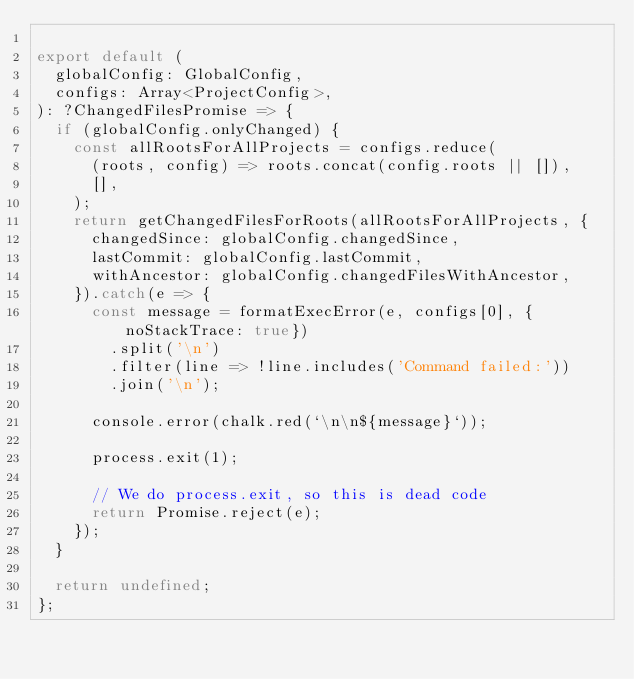<code> <loc_0><loc_0><loc_500><loc_500><_JavaScript_>
export default (
  globalConfig: GlobalConfig,
  configs: Array<ProjectConfig>,
): ?ChangedFilesPromise => {
  if (globalConfig.onlyChanged) {
    const allRootsForAllProjects = configs.reduce(
      (roots, config) => roots.concat(config.roots || []),
      [],
    );
    return getChangedFilesForRoots(allRootsForAllProjects, {
      changedSince: globalConfig.changedSince,
      lastCommit: globalConfig.lastCommit,
      withAncestor: globalConfig.changedFilesWithAncestor,
    }).catch(e => {
      const message = formatExecError(e, configs[0], {noStackTrace: true})
        .split('\n')
        .filter(line => !line.includes('Command failed:'))
        .join('\n');

      console.error(chalk.red(`\n\n${message}`));

      process.exit(1);

      // We do process.exit, so this is dead code
      return Promise.reject(e);
    });
  }

  return undefined;
};
</code> 